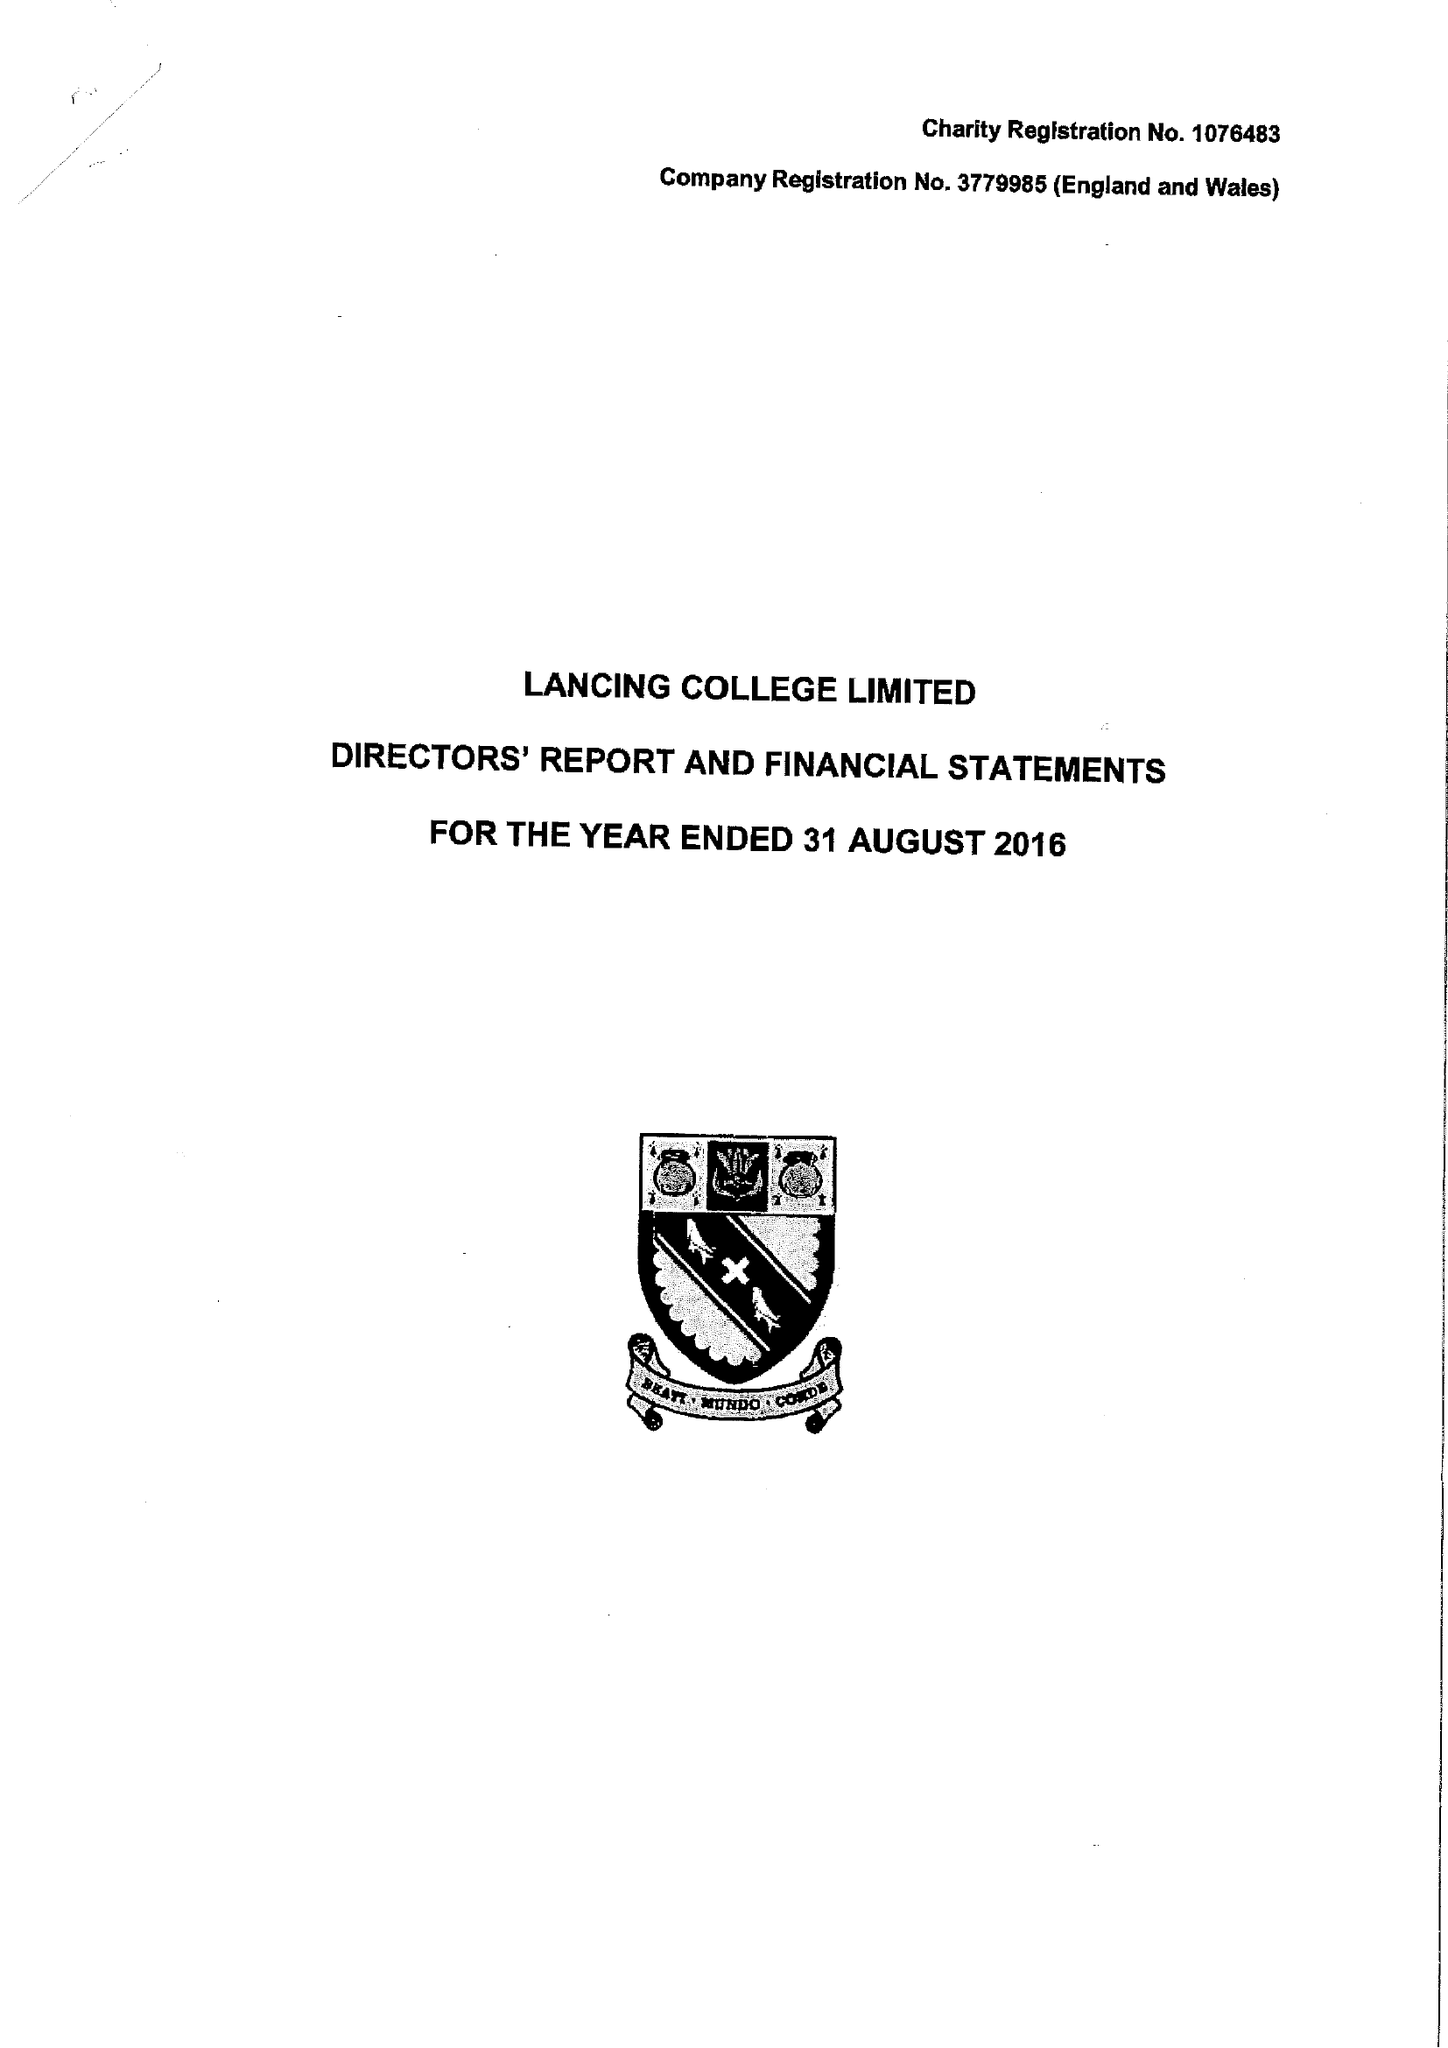What is the value for the income_annually_in_british_pounds?
Answer the question using a single word or phrase. 19700415.00 